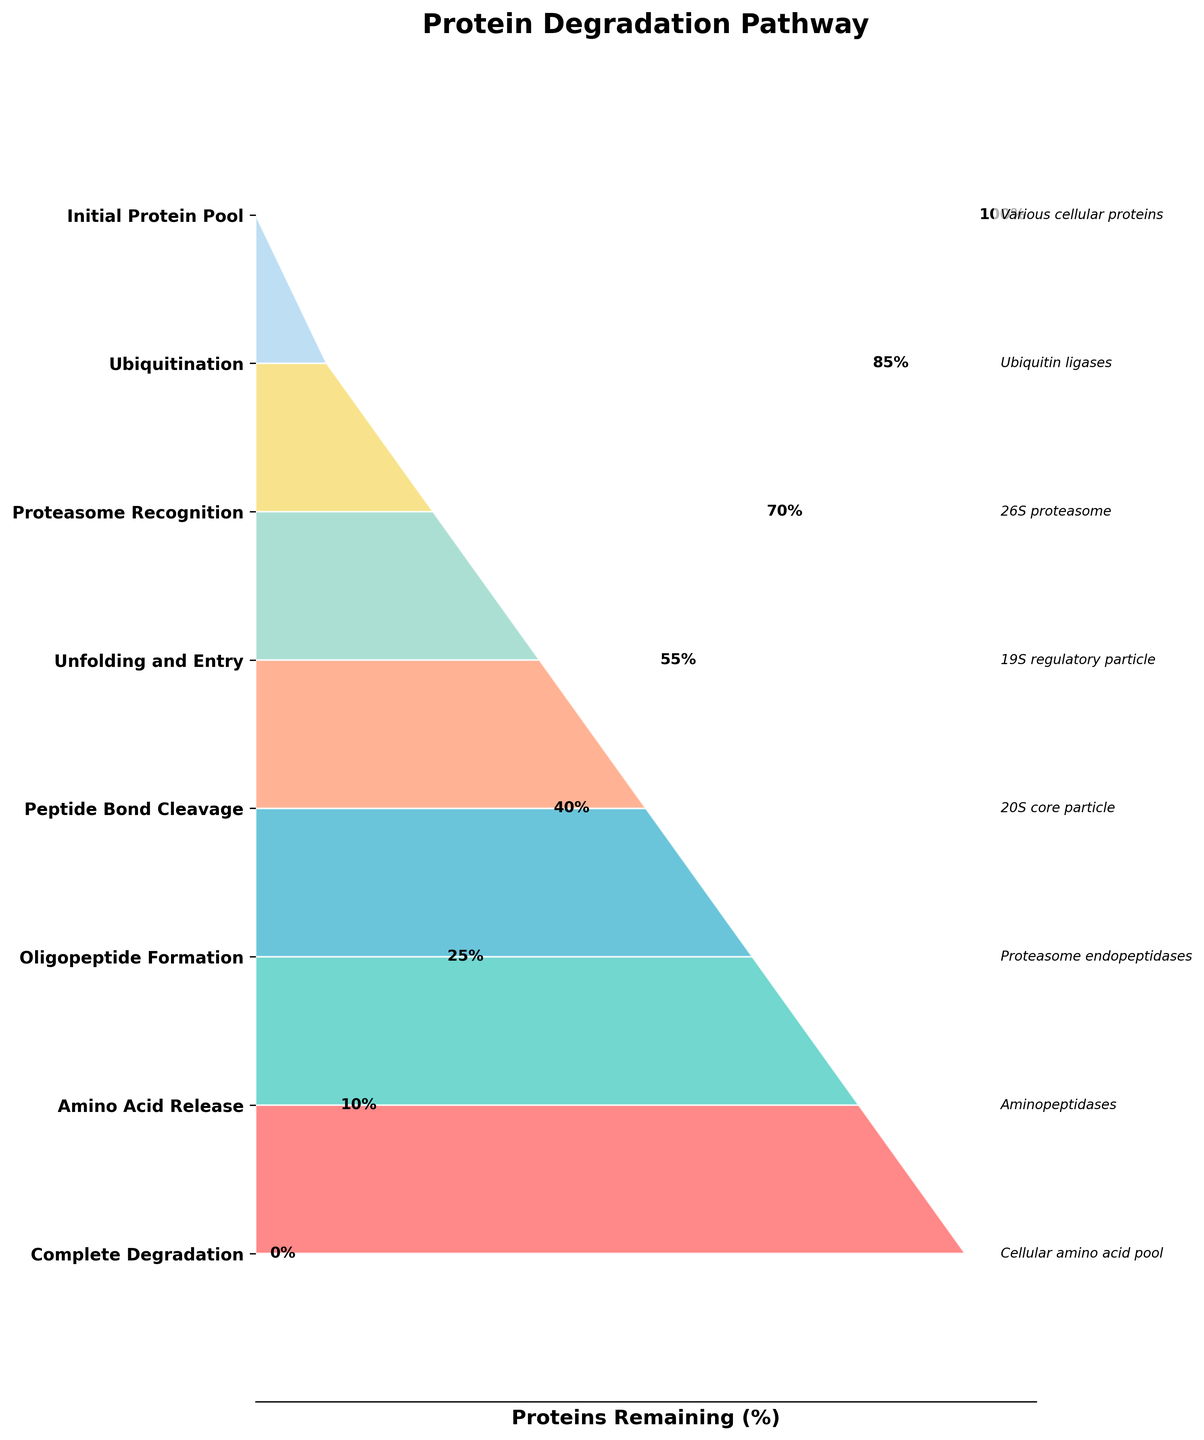Who or what is involved in the ubiquitination step? Referring to the label, the ubiquitination step is associated with the involvement of ubiquitin ligases.
Answer: ubiquitin ligases Which step results in the greatest decrease in protein percentage? By comparing the percentages from one step to the next, the transition from "Unfolding and Entry" (55%) to "Peptide Bond Cleavage" (40%) represents the greatest decrease of 15%.
Answer: Unfolding and Entry to Peptide Bond Cleavage What's the percentage of proteins remaining after the peptide bond cleavage step? The label next to Peptide Bond Cleavage states that 40% of proteins remain after this step.
Answer: 40% Which step involves the 26S proteasome? The label next to "Proteasome Recognition" indicates it involves the 26S proteasome.
Answer: Proteasome Recognition How many steps are there in the protein degradation pathway? Counting all of the labeled steps from top to bottom gives us a total of 8 steps.
Answer: 8 Which molecule is involved in the release of amino acids? The label next to "Amino Acid Release" specifies that aminopeptidases are involved in this step.
Answer: aminopeptidases What is the percentage of proteins remaining before the oligopeptide formation step? The label next to "Peptide Bond Cleavage" indicates that 40% of proteins remain before the oligopeptide formation step.
Answer: 40% Are there more or fewer proteins remaining after proteasome recognition compared to after ubiquitination? After ubiquitination, 85% of proteins remain, whereas after proteasome recognition, 70% remain. Hence, there are fewer proteins remaining after proteasome recognition.
Answer: fewer Which step occurs directly before complete degradation? Checking the steps sequentially, "Amino Acid Release" occurs directly before "Complete Degradation."
Answer: Amino Acid Release How does the percentage of proteins remaining change from the initial protein pool to the complete degradation stage? The funnel starts with 100% of proteins in the initial pool and ends with 0% in the complete degradation stage, indicating a reduction of 100%.
Answer: reduced by 100% 